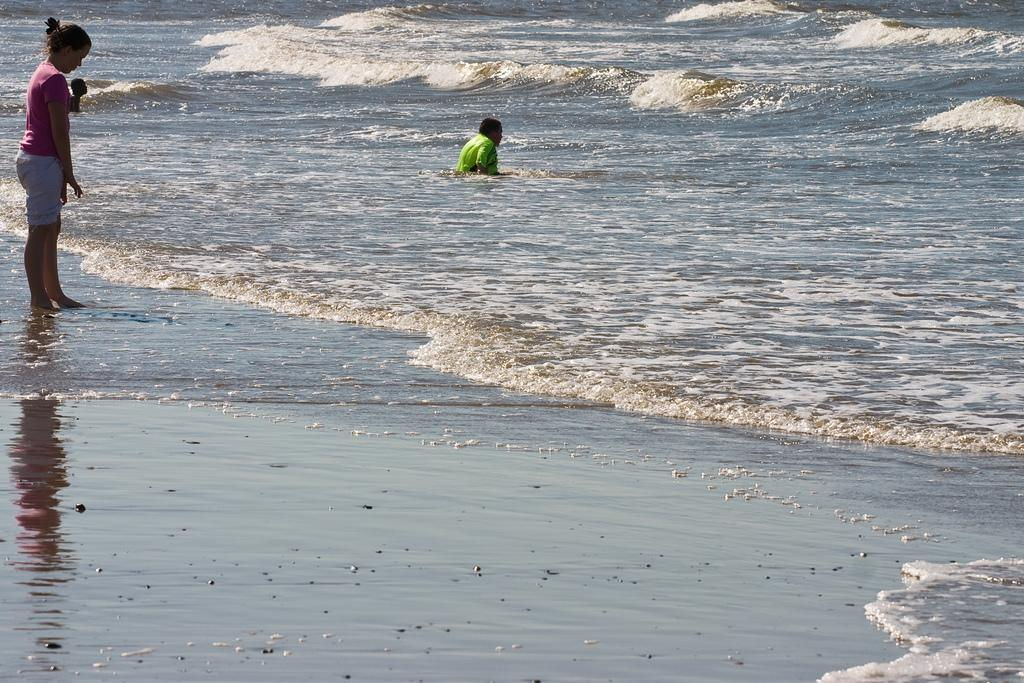What is the main subject of the image? There is a woman standing in the image. Can you describe the location of the image? The location appears to be a seashore. Are there any other people in the image? Yes, there is another person in the water. What can be seen in the background of the image? The image depicts a sea with water flowing. What substance is the woman fighting against in the image? There is no indication in the image that the woman is fighting against any substance. 